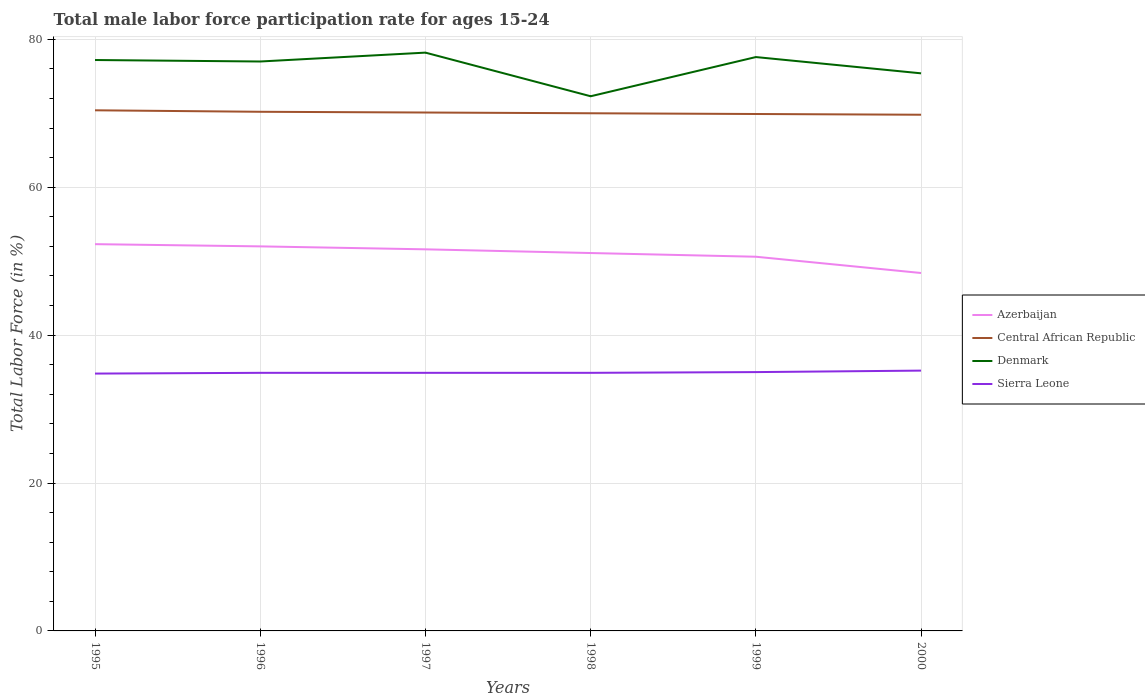How many different coloured lines are there?
Offer a terse response. 4. Does the line corresponding to Sierra Leone intersect with the line corresponding to Denmark?
Ensure brevity in your answer.  No. Is the number of lines equal to the number of legend labels?
Provide a succinct answer. Yes. Across all years, what is the maximum male labor force participation rate in Denmark?
Provide a short and direct response. 72.3. What is the total male labor force participation rate in Azerbaijan in the graph?
Provide a short and direct response. 3.9. What is the difference between the highest and the second highest male labor force participation rate in Sierra Leone?
Your answer should be very brief. 0.4. How many lines are there?
Your answer should be very brief. 4. What is the difference between two consecutive major ticks on the Y-axis?
Provide a short and direct response. 20. Are the values on the major ticks of Y-axis written in scientific E-notation?
Ensure brevity in your answer.  No. Does the graph contain any zero values?
Provide a succinct answer. No. Does the graph contain grids?
Give a very brief answer. Yes. How many legend labels are there?
Keep it short and to the point. 4. How are the legend labels stacked?
Ensure brevity in your answer.  Vertical. What is the title of the graph?
Your answer should be very brief. Total male labor force participation rate for ages 15-24. What is the label or title of the Y-axis?
Keep it short and to the point. Total Labor Force (in %). What is the Total Labor Force (in %) of Azerbaijan in 1995?
Your answer should be compact. 52.3. What is the Total Labor Force (in %) of Central African Republic in 1995?
Give a very brief answer. 70.4. What is the Total Labor Force (in %) in Denmark in 1995?
Your answer should be compact. 77.2. What is the Total Labor Force (in %) of Sierra Leone in 1995?
Make the answer very short. 34.8. What is the Total Labor Force (in %) of Central African Republic in 1996?
Give a very brief answer. 70.2. What is the Total Labor Force (in %) of Denmark in 1996?
Provide a short and direct response. 77. What is the Total Labor Force (in %) of Sierra Leone in 1996?
Ensure brevity in your answer.  34.9. What is the Total Labor Force (in %) in Azerbaijan in 1997?
Keep it short and to the point. 51.6. What is the Total Labor Force (in %) in Central African Republic in 1997?
Give a very brief answer. 70.1. What is the Total Labor Force (in %) of Denmark in 1997?
Offer a terse response. 78.2. What is the Total Labor Force (in %) in Sierra Leone in 1997?
Your answer should be very brief. 34.9. What is the Total Labor Force (in %) in Azerbaijan in 1998?
Offer a terse response. 51.1. What is the Total Labor Force (in %) of Central African Republic in 1998?
Keep it short and to the point. 70. What is the Total Labor Force (in %) in Denmark in 1998?
Your answer should be compact. 72.3. What is the Total Labor Force (in %) in Sierra Leone in 1998?
Ensure brevity in your answer.  34.9. What is the Total Labor Force (in %) of Azerbaijan in 1999?
Provide a succinct answer. 50.6. What is the Total Labor Force (in %) in Central African Republic in 1999?
Ensure brevity in your answer.  69.9. What is the Total Labor Force (in %) of Denmark in 1999?
Make the answer very short. 77.6. What is the Total Labor Force (in %) in Sierra Leone in 1999?
Your answer should be compact. 35. What is the Total Labor Force (in %) of Azerbaijan in 2000?
Provide a short and direct response. 48.4. What is the Total Labor Force (in %) in Central African Republic in 2000?
Offer a very short reply. 69.8. What is the Total Labor Force (in %) in Denmark in 2000?
Offer a very short reply. 75.4. What is the Total Labor Force (in %) in Sierra Leone in 2000?
Offer a very short reply. 35.2. Across all years, what is the maximum Total Labor Force (in %) in Azerbaijan?
Provide a succinct answer. 52.3. Across all years, what is the maximum Total Labor Force (in %) in Central African Republic?
Your answer should be compact. 70.4. Across all years, what is the maximum Total Labor Force (in %) in Denmark?
Give a very brief answer. 78.2. Across all years, what is the maximum Total Labor Force (in %) of Sierra Leone?
Give a very brief answer. 35.2. Across all years, what is the minimum Total Labor Force (in %) of Azerbaijan?
Keep it short and to the point. 48.4. Across all years, what is the minimum Total Labor Force (in %) of Central African Republic?
Give a very brief answer. 69.8. Across all years, what is the minimum Total Labor Force (in %) in Denmark?
Your answer should be very brief. 72.3. Across all years, what is the minimum Total Labor Force (in %) in Sierra Leone?
Your answer should be very brief. 34.8. What is the total Total Labor Force (in %) in Azerbaijan in the graph?
Keep it short and to the point. 306. What is the total Total Labor Force (in %) of Central African Republic in the graph?
Provide a short and direct response. 420.4. What is the total Total Labor Force (in %) in Denmark in the graph?
Offer a very short reply. 457.7. What is the total Total Labor Force (in %) in Sierra Leone in the graph?
Provide a succinct answer. 209.7. What is the difference between the Total Labor Force (in %) of Central African Republic in 1995 and that in 1997?
Provide a succinct answer. 0.3. What is the difference between the Total Labor Force (in %) in Sierra Leone in 1995 and that in 1997?
Offer a terse response. -0.1. What is the difference between the Total Labor Force (in %) in Azerbaijan in 1995 and that in 1998?
Your answer should be very brief. 1.2. What is the difference between the Total Labor Force (in %) in Central African Republic in 1995 and that in 1999?
Make the answer very short. 0.5. What is the difference between the Total Labor Force (in %) in Sierra Leone in 1995 and that in 1999?
Ensure brevity in your answer.  -0.2. What is the difference between the Total Labor Force (in %) in Central African Republic in 1995 and that in 2000?
Offer a very short reply. 0.6. What is the difference between the Total Labor Force (in %) of Sierra Leone in 1995 and that in 2000?
Make the answer very short. -0.4. What is the difference between the Total Labor Force (in %) in Central African Republic in 1996 and that in 1997?
Your answer should be compact. 0.1. What is the difference between the Total Labor Force (in %) in Denmark in 1996 and that in 1997?
Make the answer very short. -1.2. What is the difference between the Total Labor Force (in %) of Central African Republic in 1996 and that in 1998?
Provide a succinct answer. 0.2. What is the difference between the Total Labor Force (in %) in Denmark in 1996 and that in 1999?
Provide a short and direct response. -0.6. What is the difference between the Total Labor Force (in %) of Sierra Leone in 1996 and that in 1999?
Give a very brief answer. -0.1. What is the difference between the Total Labor Force (in %) of Azerbaijan in 1996 and that in 2000?
Your answer should be very brief. 3.6. What is the difference between the Total Labor Force (in %) in Denmark in 1996 and that in 2000?
Give a very brief answer. 1.6. What is the difference between the Total Labor Force (in %) of Azerbaijan in 1997 and that in 1998?
Offer a terse response. 0.5. What is the difference between the Total Labor Force (in %) of Denmark in 1997 and that in 1998?
Make the answer very short. 5.9. What is the difference between the Total Labor Force (in %) of Azerbaijan in 1997 and that in 1999?
Your answer should be compact. 1. What is the difference between the Total Labor Force (in %) in Central African Republic in 1997 and that in 1999?
Keep it short and to the point. 0.2. What is the difference between the Total Labor Force (in %) in Denmark in 1997 and that in 1999?
Provide a succinct answer. 0.6. What is the difference between the Total Labor Force (in %) of Sierra Leone in 1997 and that in 1999?
Ensure brevity in your answer.  -0.1. What is the difference between the Total Labor Force (in %) in Azerbaijan in 1997 and that in 2000?
Offer a terse response. 3.2. What is the difference between the Total Labor Force (in %) of Central African Republic in 1997 and that in 2000?
Your answer should be very brief. 0.3. What is the difference between the Total Labor Force (in %) of Denmark in 1997 and that in 2000?
Offer a terse response. 2.8. What is the difference between the Total Labor Force (in %) in Central African Republic in 1998 and that in 1999?
Offer a very short reply. 0.1. What is the difference between the Total Labor Force (in %) of Sierra Leone in 1998 and that in 1999?
Your answer should be very brief. -0.1. What is the difference between the Total Labor Force (in %) of Azerbaijan in 1998 and that in 2000?
Offer a terse response. 2.7. What is the difference between the Total Labor Force (in %) in Central African Republic in 1998 and that in 2000?
Make the answer very short. 0.2. What is the difference between the Total Labor Force (in %) of Sierra Leone in 1998 and that in 2000?
Provide a short and direct response. -0.3. What is the difference between the Total Labor Force (in %) of Central African Republic in 1999 and that in 2000?
Provide a succinct answer. 0.1. What is the difference between the Total Labor Force (in %) of Azerbaijan in 1995 and the Total Labor Force (in %) of Central African Republic in 1996?
Make the answer very short. -17.9. What is the difference between the Total Labor Force (in %) of Azerbaijan in 1995 and the Total Labor Force (in %) of Denmark in 1996?
Offer a terse response. -24.7. What is the difference between the Total Labor Force (in %) of Azerbaijan in 1995 and the Total Labor Force (in %) of Sierra Leone in 1996?
Ensure brevity in your answer.  17.4. What is the difference between the Total Labor Force (in %) in Central African Republic in 1995 and the Total Labor Force (in %) in Sierra Leone in 1996?
Your answer should be compact. 35.5. What is the difference between the Total Labor Force (in %) of Denmark in 1995 and the Total Labor Force (in %) of Sierra Leone in 1996?
Give a very brief answer. 42.3. What is the difference between the Total Labor Force (in %) in Azerbaijan in 1995 and the Total Labor Force (in %) in Central African Republic in 1997?
Your response must be concise. -17.8. What is the difference between the Total Labor Force (in %) in Azerbaijan in 1995 and the Total Labor Force (in %) in Denmark in 1997?
Provide a succinct answer. -25.9. What is the difference between the Total Labor Force (in %) of Central African Republic in 1995 and the Total Labor Force (in %) of Sierra Leone in 1997?
Ensure brevity in your answer.  35.5. What is the difference between the Total Labor Force (in %) of Denmark in 1995 and the Total Labor Force (in %) of Sierra Leone in 1997?
Your answer should be compact. 42.3. What is the difference between the Total Labor Force (in %) of Azerbaijan in 1995 and the Total Labor Force (in %) of Central African Republic in 1998?
Offer a terse response. -17.7. What is the difference between the Total Labor Force (in %) of Azerbaijan in 1995 and the Total Labor Force (in %) of Denmark in 1998?
Give a very brief answer. -20. What is the difference between the Total Labor Force (in %) in Central African Republic in 1995 and the Total Labor Force (in %) in Denmark in 1998?
Provide a short and direct response. -1.9. What is the difference between the Total Labor Force (in %) of Central African Republic in 1995 and the Total Labor Force (in %) of Sierra Leone in 1998?
Provide a short and direct response. 35.5. What is the difference between the Total Labor Force (in %) in Denmark in 1995 and the Total Labor Force (in %) in Sierra Leone in 1998?
Provide a succinct answer. 42.3. What is the difference between the Total Labor Force (in %) in Azerbaijan in 1995 and the Total Labor Force (in %) in Central African Republic in 1999?
Provide a succinct answer. -17.6. What is the difference between the Total Labor Force (in %) in Azerbaijan in 1995 and the Total Labor Force (in %) in Denmark in 1999?
Give a very brief answer. -25.3. What is the difference between the Total Labor Force (in %) in Azerbaijan in 1995 and the Total Labor Force (in %) in Sierra Leone in 1999?
Offer a terse response. 17.3. What is the difference between the Total Labor Force (in %) of Central African Republic in 1995 and the Total Labor Force (in %) of Denmark in 1999?
Provide a succinct answer. -7.2. What is the difference between the Total Labor Force (in %) in Central African Republic in 1995 and the Total Labor Force (in %) in Sierra Leone in 1999?
Your response must be concise. 35.4. What is the difference between the Total Labor Force (in %) of Denmark in 1995 and the Total Labor Force (in %) of Sierra Leone in 1999?
Provide a succinct answer. 42.2. What is the difference between the Total Labor Force (in %) of Azerbaijan in 1995 and the Total Labor Force (in %) of Central African Republic in 2000?
Make the answer very short. -17.5. What is the difference between the Total Labor Force (in %) in Azerbaijan in 1995 and the Total Labor Force (in %) in Denmark in 2000?
Ensure brevity in your answer.  -23.1. What is the difference between the Total Labor Force (in %) in Central African Republic in 1995 and the Total Labor Force (in %) in Denmark in 2000?
Offer a very short reply. -5. What is the difference between the Total Labor Force (in %) in Central African Republic in 1995 and the Total Labor Force (in %) in Sierra Leone in 2000?
Provide a succinct answer. 35.2. What is the difference between the Total Labor Force (in %) of Denmark in 1995 and the Total Labor Force (in %) of Sierra Leone in 2000?
Provide a succinct answer. 42. What is the difference between the Total Labor Force (in %) in Azerbaijan in 1996 and the Total Labor Force (in %) in Central African Republic in 1997?
Your response must be concise. -18.1. What is the difference between the Total Labor Force (in %) in Azerbaijan in 1996 and the Total Labor Force (in %) in Denmark in 1997?
Offer a very short reply. -26.2. What is the difference between the Total Labor Force (in %) of Central African Republic in 1996 and the Total Labor Force (in %) of Denmark in 1997?
Your answer should be compact. -8. What is the difference between the Total Labor Force (in %) of Central African Republic in 1996 and the Total Labor Force (in %) of Sierra Leone in 1997?
Your answer should be compact. 35.3. What is the difference between the Total Labor Force (in %) of Denmark in 1996 and the Total Labor Force (in %) of Sierra Leone in 1997?
Your response must be concise. 42.1. What is the difference between the Total Labor Force (in %) of Azerbaijan in 1996 and the Total Labor Force (in %) of Central African Republic in 1998?
Offer a very short reply. -18. What is the difference between the Total Labor Force (in %) of Azerbaijan in 1996 and the Total Labor Force (in %) of Denmark in 1998?
Provide a short and direct response. -20.3. What is the difference between the Total Labor Force (in %) in Azerbaijan in 1996 and the Total Labor Force (in %) in Sierra Leone in 1998?
Your answer should be compact. 17.1. What is the difference between the Total Labor Force (in %) of Central African Republic in 1996 and the Total Labor Force (in %) of Denmark in 1998?
Offer a terse response. -2.1. What is the difference between the Total Labor Force (in %) of Central African Republic in 1996 and the Total Labor Force (in %) of Sierra Leone in 1998?
Offer a terse response. 35.3. What is the difference between the Total Labor Force (in %) in Denmark in 1996 and the Total Labor Force (in %) in Sierra Leone in 1998?
Provide a succinct answer. 42.1. What is the difference between the Total Labor Force (in %) in Azerbaijan in 1996 and the Total Labor Force (in %) in Central African Republic in 1999?
Your answer should be very brief. -17.9. What is the difference between the Total Labor Force (in %) in Azerbaijan in 1996 and the Total Labor Force (in %) in Denmark in 1999?
Give a very brief answer. -25.6. What is the difference between the Total Labor Force (in %) in Central African Republic in 1996 and the Total Labor Force (in %) in Denmark in 1999?
Offer a very short reply. -7.4. What is the difference between the Total Labor Force (in %) of Central African Republic in 1996 and the Total Labor Force (in %) of Sierra Leone in 1999?
Offer a very short reply. 35.2. What is the difference between the Total Labor Force (in %) of Azerbaijan in 1996 and the Total Labor Force (in %) of Central African Republic in 2000?
Your answer should be very brief. -17.8. What is the difference between the Total Labor Force (in %) of Azerbaijan in 1996 and the Total Labor Force (in %) of Denmark in 2000?
Give a very brief answer. -23.4. What is the difference between the Total Labor Force (in %) in Azerbaijan in 1996 and the Total Labor Force (in %) in Sierra Leone in 2000?
Your answer should be compact. 16.8. What is the difference between the Total Labor Force (in %) in Denmark in 1996 and the Total Labor Force (in %) in Sierra Leone in 2000?
Provide a short and direct response. 41.8. What is the difference between the Total Labor Force (in %) in Azerbaijan in 1997 and the Total Labor Force (in %) in Central African Republic in 1998?
Ensure brevity in your answer.  -18.4. What is the difference between the Total Labor Force (in %) of Azerbaijan in 1997 and the Total Labor Force (in %) of Denmark in 1998?
Keep it short and to the point. -20.7. What is the difference between the Total Labor Force (in %) of Central African Republic in 1997 and the Total Labor Force (in %) of Denmark in 1998?
Keep it short and to the point. -2.2. What is the difference between the Total Labor Force (in %) in Central African Republic in 1997 and the Total Labor Force (in %) in Sierra Leone in 1998?
Give a very brief answer. 35.2. What is the difference between the Total Labor Force (in %) of Denmark in 1997 and the Total Labor Force (in %) of Sierra Leone in 1998?
Provide a succinct answer. 43.3. What is the difference between the Total Labor Force (in %) of Azerbaijan in 1997 and the Total Labor Force (in %) of Central African Republic in 1999?
Your answer should be compact. -18.3. What is the difference between the Total Labor Force (in %) of Azerbaijan in 1997 and the Total Labor Force (in %) of Denmark in 1999?
Provide a short and direct response. -26. What is the difference between the Total Labor Force (in %) in Central African Republic in 1997 and the Total Labor Force (in %) in Sierra Leone in 1999?
Provide a short and direct response. 35.1. What is the difference between the Total Labor Force (in %) in Denmark in 1997 and the Total Labor Force (in %) in Sierra Leone in 1999?
Your answer should be very brief. 43.2. What is the difference between the Total Labor Force (in %) of Azerbaijan in 1997 and the Total Labor Force (in %) of Central African Republic in 2000?
Provide a succinct answer. -18.2. What is the difference between the Total Labor Force (in %) in Azerbaijan in 1997 and the Total Labor Force (in %) in Denmark in 2000?
Your response must be concise. -23.8. What is the difference between the Total Labor Force (in %) in Azerbaijan in 1997 and the Total Labor Force (in %) in Sierra Leone in 2000?
Your answer should be very brief. 16.4. What is the difference between the Total Labor Force (in %) of Central African Republic in 1997 and the Total Labor Force (in %) of Sierra Leone in 2000?
Give a very brief answer. 34.9. What is the difference between the Total Labor Force (in %) of Azerbaijan in 1998 and the Total Labor Force (in %) of Central African Republic in 1999?
Give a very brief answer. -18.8. What is the difference between the Total Labor Force (in %) of Azerbaijan in 1998 and the Total Labor Force (in %) of Denmark in 1999?
Provide a succinct answer. -26.5. What is the difference between the Total Labor Force (in %) of Denmark in 1998 and the Total Labor Force (in %) of Sierra Leone in 1999?
Keep it short and to the point. 37.3. What is the difference between the Total Labor Force (in %) in Azerbaijan in 1998 and the Total Labor Force (in %) in Central African Republic in 2000?
Your answer should be compact. -18.7. What is the difference between the Total Labor Force (in %) in Azerbaijan in 1998 and the Total Labor Force (in %) in Denmark in 2000?
Your response must be concise. -24.3. What is the difference between the Total Labor Force (in %) of Central African Republic in 1998 and the Total Labor Force (in %) of Denmark in 2000?
Your response must be concise. -5.4. What is the difference between the Total Labor Force (in %) in Central African Republic in 1998 and the Total Labor Force (in %) in Sierra Leone in 2000?
Provide a short and direct response. 34.8. What is the difference between the Total Labor Force (in %) in Denmark in 1998 and the Total Labor Force (in %) in Sierra Leone in 2000?
Your response must be concise. 37.1. What is the difference between the Total Labor Force (in %) of Azerbaijan in 1999 and the Total Labor Force (in %) of Central African Republic in 2000?
Offer a very short reply. -19.2. What is the difference between the Total Labor Force (in %) in Azerbaijan in 1999 and the Total Labor Force (in %) in Denmark in 2000?
Offer a very short reply. -24.8. What is the difference between the Total Labor Force (in %) in Azerbaijan in 1999 and the Total Labor Force (in %) in Sierra Leone in 2000?
Give a very brief answer. 15.4. What is the difference between the Total Labor Force (in %) in Central African Republic in 1999 and the Total Labor Force (in %) in Sierra Leone in 2000?
Your answer should be very brief. 34.7. What is the difference between the Total Labor Force (in %) in Denmark in 1999 and the Total Labor Force (in %) in Sierra Leone in 2000?
Give a very brief answer. 42.4. What is the average Total Labor Force (in %) of Azerbaijan per year?
Your answer should be compact. 51. What is the average Total Labor Force (in %) of Central African Republic per year?
Make the answer very short. 70.07. What is the average Total Labor Force (in %) in Denmark per year?
Provide a succinct answer. 76.28. What is the average Total Labor Force (in %) of Sierra Leone per year?
Offer a terse response. 34.95. In the year 1995, what is the difference between the Total Labor Force (in %) in Azerbaijan and Total Labor Force (in %) in Central African Republic?
Your answer should be compact. -18.1. In the year 1995, what is the difference between the Total Labor Force (in %) of Azerbaijan and Total Labor Force (in %) of Denmark?
Your response must be concise. -24.9. In the year 1995, what is the difference between the Total Labor Force (in %) of Central African Republic and Total Labor Force (in %) of Denmark?
Provide a short and direct response. -6.8. In the year 1995, what is the difference between the Total Labor Force (in %) of Central African Republic and Total Labor Force (in %) of Sierra Leone?
Your answer should be compact. 35.6. In the year 1995, what is the difference between the Total Labor Force (in %) of Denmark and Total Labor Force (in %) of Sierra Leone?
Your answer should be very brief. 42.4. In the year 1996, what is the difference between the Total Labor Force (in %) of Azerbaijan and Total Labor Force (in %) of Central African Republic?
Your response must be concise. -18.2. In the year 1996, what is the difference between the Total Labor Force (in %) of Azerbaijan and Total Labor Force (in %) of Sierra Leone?
Keep it short and to the point. 17.1. In the year 1996, what is the difference between the Total Labor Force (in %) of Central African Republic and Total Labor Force (in %) of Sierra Leone?
Provide a succinct answer. 35.3. In the year 1996, what is the difference between the Total Labor Force (in %) of Denmark and Total Labor Force (in %) of Sierra Leone?
Provide a short and direct response. 42.1. In the year 1997, what is the difference between the Total Labor Force (in %) of Azerbaijan and Total Labor Force (in %) of Central African Republic?
Keep it short and to the point. -18.5. In the year 1997, what is the difference between the Total Labor Force (in %) in Azerbaijan and Total Labor Force (in %) in Denmark?
Make the answer very short. -26.6. In the year 1997, what is the difference between the Total Labor Force (in %) of Central African Republic and Total Labor Force (in %) of Denmark?
Offer a terse response. -8.1. In the year 1997, what is the difference between the Total Labor Force (in %) in Central African Republic and Total Labor Force (in %) in Sierra Leone?
Make the answer very short. 35.2. In the year 1997, what is the difference between the Total Labor Force (in %) of Denmark and Total Labor Force (in %) of Sierra Leone?
Your answer should be compact. 43.3. In the year 1998, what is the difference between the Total Labor Force (in %) in Azerbaijan and Total Labor Force (in %) in Central African Republic?
Offer a terse response. -18.9. In the year 1998, what is the difference between the Total Labor Force (in %) of Azerbaijan and Total Labor Force (in %) of Denmark?
Offer a terse response. -21.2. In the year 1998, what is the difference between the Total Labor Force (in %) in Azerbaijan and Total Labor Force (in %) in Sierra Leone?
Keep it short and to the point. 16.2. In the year 1998, what is the difference between the Total Labor Force (in %) in Central African Republic and Total Labor Force (in %) in Denmark?
Your answer should be compact. -2.3. In the year 1998, what is the difference between the Total Labor Force (in %) in Central African Republic and Total Labor Force (in %) in Sierra Leone?
Ensure brevity in your answer.  35.1. In the year 1998, what is the difference between the Total Labor Force (in %) of Denmark and Total Labor Force (in %) of Sierra Leone?
Offer a terse response. 37.4. In the year 1999, what is the difference between the Total Labor Force (in %) of Azerbaijan and Total Labor Force (in %) of Central African Republic?
Your answer should be compact. -19.3. In the year 1999, what is the difference between the Total Labor Force (in %) in Central African Republic and Total Labor Force (in %) in Denmark?
Keep it short and to the point. -7.7. In the year 1999, what is the difference between the Total Labor Force (in %) in Central African Republic and Total Labor Force (in %) in Sierra Leone?
Provide a succinct answer. 34.9. In the year 1999, what is the difference between the Total Labor Force (in %) in Denmark and Total Labor Force (in %) in Sierra Leone?
Make the answer very short. 42.6. In the year 2000, what is the difference between the Total Labor Force (in %) in Azerbaijan and Total Labor Force (in %) in Central African Republic?
Offer a terse response. -21.4. In the year 2000, what is the difference between the Total Labor Force (in %) of Central African Republic and Total Labor Force (in %) of Denmark?
Offer a terse response. -5.6. In the year 2000, what is the difference between the Total Labor Force (in %) in Central African Republic and Total Labor Force (in %) in Sierra Leone?
Offer a very short reply. 34.6. In the year 2000, what is the difference between the Total Labor Force (in %) in Denmark and Total Labor Force (in %) in Sierra Leone?
Your response must be concise. 40.2. What is the ratio of the Total Labor Force (in %) of Azerbaijan in 1995 to that in 1996?
Offer a terse response. 1.01. What is the ratio of the Total Labor Force (in %) of Central African Republic in 1995 to that in 1996?
Provide a short and direct response. 1. What is the ratio of the Total Labor Force (in %) of Denmark in 1995 to that in 1996?
Your answer should be compact. 1. What is the ratio of the Total Labor Force (in %) in Sierra Leone in 1995 to that in 1996?
Provide a succinct answer. 1. What is the ratio of the Total Labor Force (in %) in Azerbaijan in 1995 to that in 1997?
Provide a succinct answer. 1.01. What is the ratio of the Total Labor Force (in %) of Central African Republic in 1995 to that in 1997?
Keep it short and to the point. 1. What is the ratio of the Total Labor Force (in %) of Denmark in 1995 to that in 1997?
Your response must be concise. 0.99. What is the ratio of the Total Labor Force (in %) in Sierra Leone in 1995 to that in 1997?
Provide a short and direct response. 1. What is the ratio of the Total Labor Force (in %) in Azerbaijan in 1995 to that in 1998?
Offer a terse response. 1.02. What is the ratio of the Total Labor Force (in %) of Central African Republic in 1995 to that in 1998?
Offer a terse response. 1.01. What is the ratio of the Total Labor Force (in %) of Denmark in 1995 to that in 1998?
Offer a very short reply. 1.07. What is the ratio of the Total Labor Force (in %) of Azerbaijan in 1995 to that in 1999?
Give a very brief answer. 1.03. What is the ratio of the Total Labor Force (in %) in Sierra Leone in 1995 to that in 1999?
Give a very brief answer. 0.99. What is the ratio of the Total Labor Force (in %) of Azerbaijan in 1995 to that in 2000?
Offer a terse response. 1.08. What is the ratio of the Total Labor Force (in %) of Central African Republic in 1995 to that in 2000?
Ensure brevity in your answer.  1.01. What is the ratio of the Total Labor Force (in %) in Denmark in 1995 to that in 2000?
Offer a terse response. 1.02. What is the ratio of the Total Labor Force (in %) of Azerbaijan in 1996 to that in 1997?
Offer a terse response. 1.01. What is the ratio of the Total Labor Force (in %) of Central African Republic in 1996 to that in 1997?
Offer a terse response. 1. What is the ratio of the Total Labor Force (in %) in Denmark in 1996 to that in 1997?
Your response must be concise. 0.98. What is the ratio of the Total Labor Force (in %) of Sierra Leone in 1996 to that in 1997?
Offer a terse response. 1. What is the ratio of the Total Labor Force (in %) in Azerbaijan in 1996 to that in 1998?
Give a very brief answer. 1.02. What is the ratio of the Total Labor Force (in %) of Denmark in 1996 to that in 1998?
Keep it short and to the point. 1.06. What is the ratio of the Total Labor Force (in %) of Azerbaijan in 1996 to that in 1999?
Ensure brevity in your answer.  1.03. What is the ratio of the Total Labor Force (in %) in Central African Republic in 1996 to that in 1999?
Ensure brevity in your answer.  1. What is the ratio of the Total Labor Force (in %) of Denmark in 1996 to that in 1999?
Provide a short and direct response. 0.99. What is the ratio of the Total Labor Force (in %) of Azerbaijan in 1996 to that in 2000?
Ensure brevity in your answer.  1.07. What is the ratio of the Total Labor Force (in %) of Central African Republic in 1996 to that in 2000?
Your answer should be compact. 1.01. What is the ratio of the Total Labor Force (in %) in Denmark in 1996 to that in 2000?
Offer a terse response. 1.02. What is the ratio of the Total Labor Force (in %) of Sierra Leone in 1996 to that in 2000?
Your response must be concise. 0.99. What is the ratio of the Total Labor Force (in %) in Azerbaijan in 1997 to that in 1998?
Offer a very short reply. 1.01. What is the ratio of the Total Labor Force (in %) of Central African Republic in 1997 to that in 1998?
Offer a terse response. 1. What is the ratio of the Total Labor Force (in %) in Denmark in 1997 to that in 1998?
Ensure brevity in your answer.  1.08. What is the ratio of the Total Labor Force (in %) in Azerbaijan in 1997 to that in 1999?
Keep it short and to the point. 1.02. What is the ratio of the Total Labor Force (in %) in Denmark in 1997 to that in 1999?
Offer a terse response. 1.01. What is the ratio of the Total Labor Force (in %) in Azerbaijan in 1997 to that in 2000?
Ensure brevity in your answer.  1.07. What is the ratio of the Total Labor Force (in %) in Denmark in 1997 to that in 2000?
Your answer should be compact. 1.04. What is the ratio of the Total Labor Force (in %) in Sierra Leone in 1997 to that in 2000?
Your answer should be compact. 0.99. What is the ratio of the Total Labor Force (in %) of Azerbaijan in 1998 to that in 1999?
Make the answer very short. 1.01. What is the ratio of the Total Labor Force (in %) in Denmark in 1998 to that in 1999?
Your answer should be compact. 0.93. What is the ratio of the Total Labor Force (in %) of Azerbaijan in 1998 to that in 2000?
Give a very brief answer. 1.06. What is the ratio of the Total Labor Force (in %) of Denmark in 1998 to that in 2000?
Keep it short and to the point. 0.96. What is the ratio of the Total Labor Force (in %) of Sierra Leone in 1998 to that in 2000?
Keep it short and to the point. 0.99. What is the ratio of the Total Labor Force (in %) of Azerbaijan in 1999 to that in 2000?
Keep it short and to the point. 1.05. What is the ratio of the Total Labor Force (in %) in Denmark in 1999 to that in 2000?
Your answer should be very brief. 1.03. What is the ratio of the Total Labor Force (in %) in Sierra Leone in 1999 to that in 2000?
Provide a succinct answer. 0.99. What is the difference between the highest and the second highest Total Labor Force (in %) of Azerbaijan?
Offer a terse response. 0.3. What is the difference between the highest and the second highest Total Labor Force (in %) in Denmark?
Keep it short and to the point. 0.6. What is the difference between the highest and the second highest Total Labor Force (in %) in Sierra Leone?
Provide a short and direct response. 0.2. What is the difference between the highest and the lowest Total Labor Force (in %) in Denmark?
Keep it short and to the point. 5.9. What is the difference between the highest and the lowest Total Labor Force (in %) of Sierra Leone?
Your answer should be very brief. 0.4. 